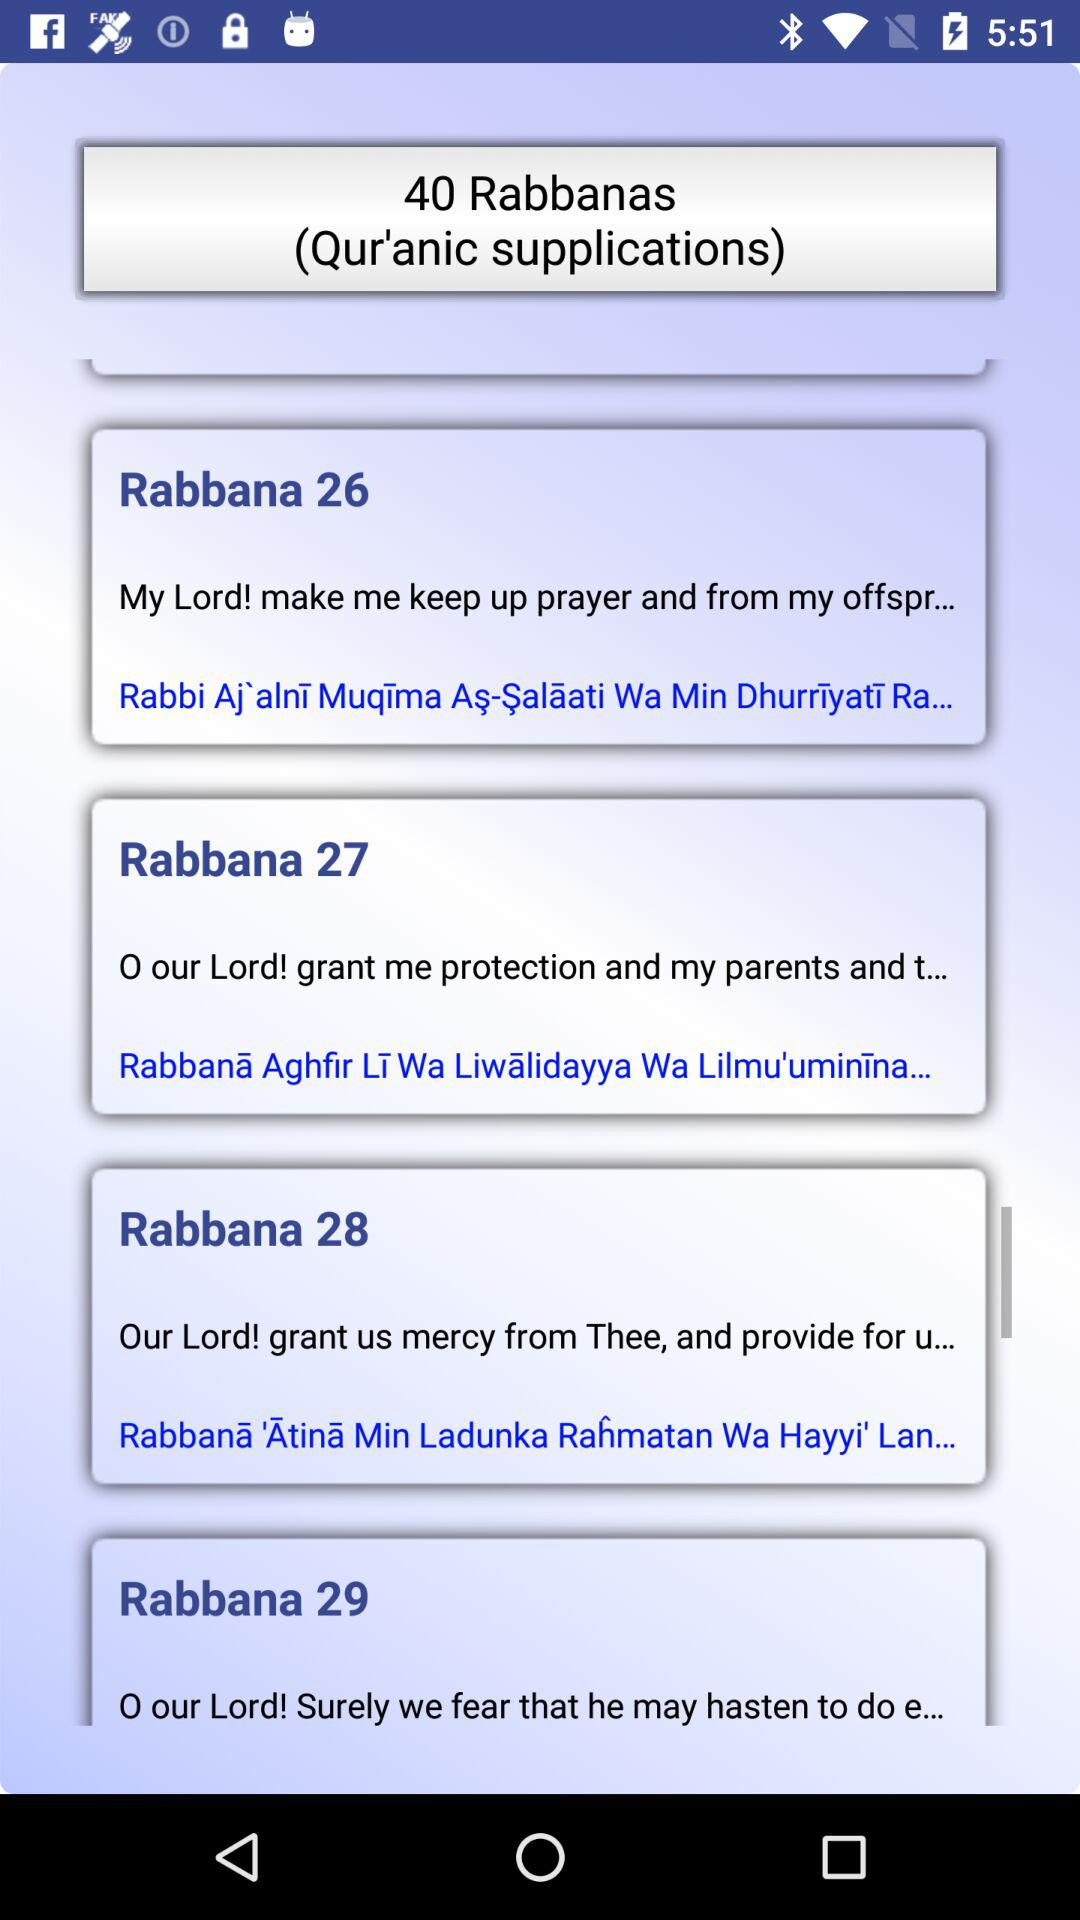How many Rabbana supplications are there on this screen?
Answer the question using a single word or phrase. 4 